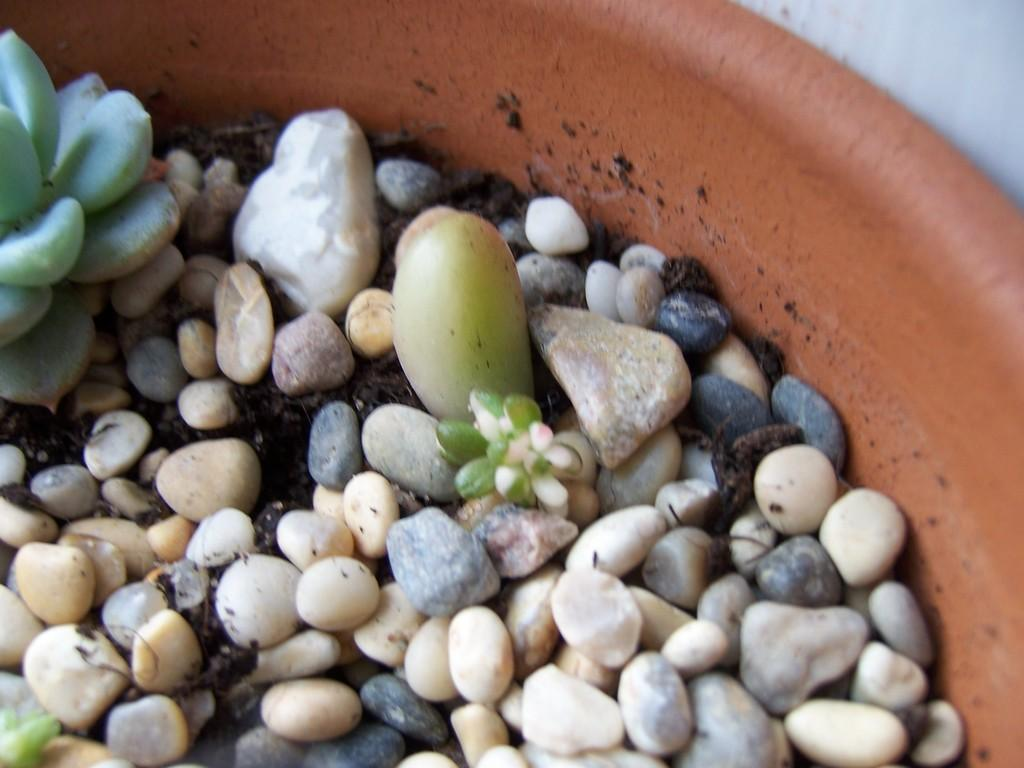What is the main object in the image? There is a pot in the image. What color is the pot? The pot is brown in color. What other objects can be seen in the image? There are stones in the image. What colors are the stones? The stones are white, cream, grey, and black in color. How many pears are sitting on the can in the image? There are no pears or cans present in the image. What type of line is drawn across the image? There is no line drawn across the image. 